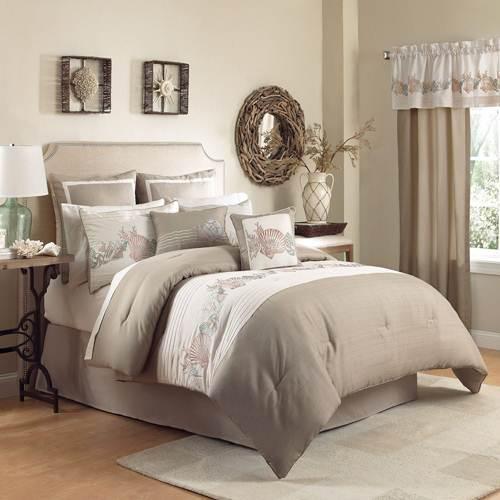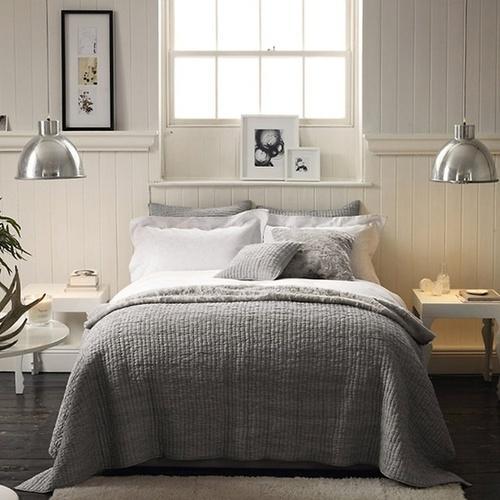The first image is the image on the left, the second image is the image on the right. Considering the images on both sides, is "Each image features a bed made up with different pillows." valid? Answer yes or no. Yes. The first image is the image on the left, the second image is the image on the right. For the images displayed, is the sentence "A window is letting in natural light." factually correct? Answer yes or no. Yes. 